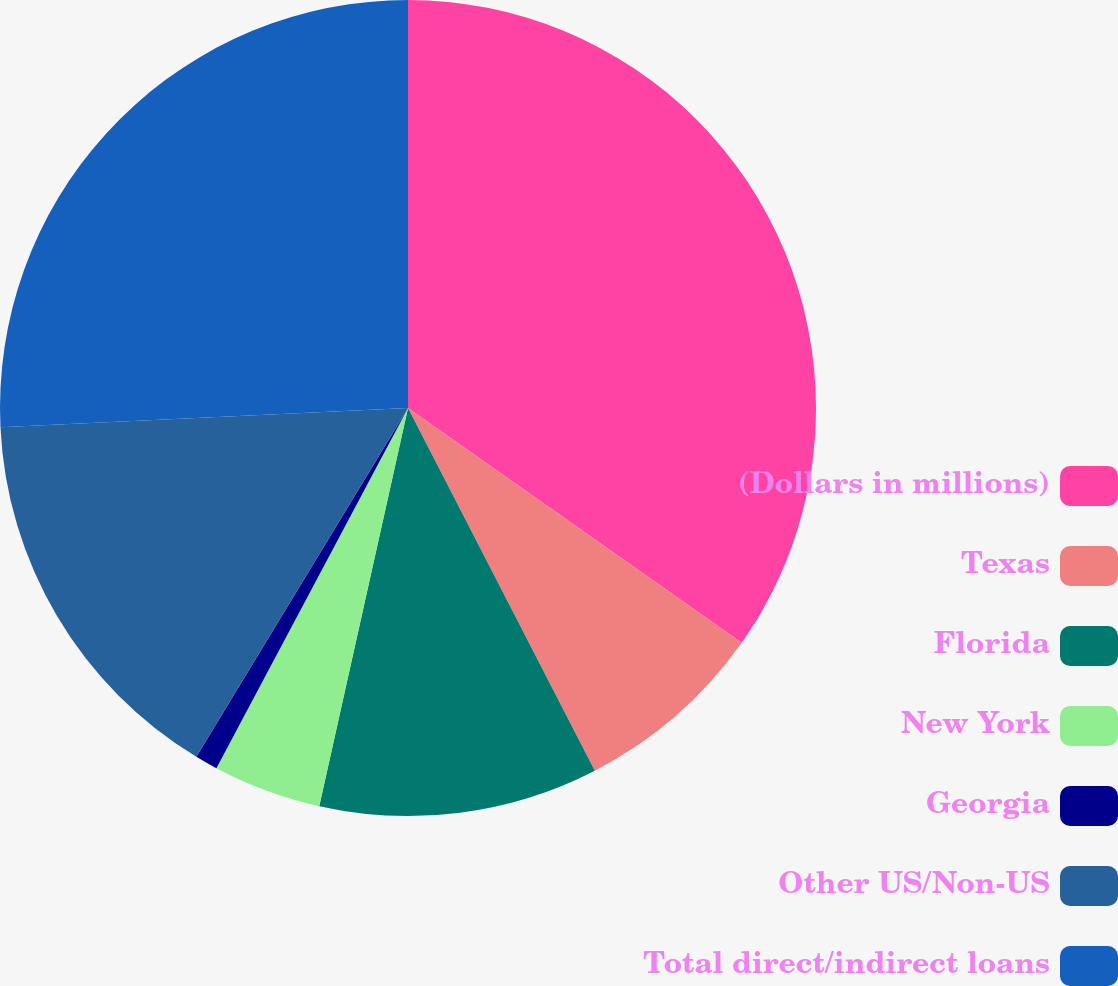Convert chart to OTSL. <chart><loc_0><loc_0><loc_500><loc_500><pie_chart><fcel>(Dollars in millions)<fcel>Texas<fcel>Florida<fcel>New York<fcel>Georgia<fcel>Other US/Non-US<fcel>Total direct/indirect loans<nl><fcel>34.76%<fcel>7.67%<fcel>11.06%<fcel>4.29%<fcel>0.9%<fcel>15.57%<fcel>25.75%<nl></chart> 